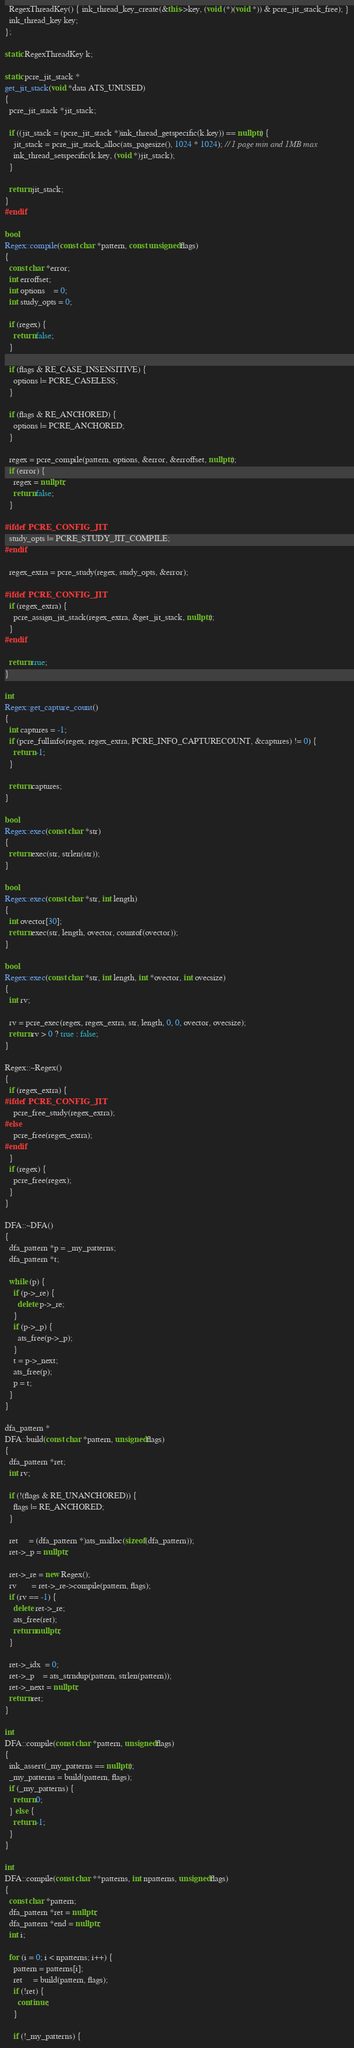<code> <loc_0><loc_0><loc_500><loc_500><_C++_>  RegexThreadKey() { ink_thread_key_create(&this->key, (void (*)(void *)) & pcre_jit_stack_free); }
  ink_thread_key key;
};

static RegexThreadKey k;

static pcre_jit_stack *
get_jit_stack(void *data ATS_UNUSED)
{
  pcre_jit_stack *jit_stack;

  if ((jit_stack = (pcre_jit_stack *)ink_thread_getspecific(k.key)) == nullptr) {
    jit_stack = pcre_jit_stack_alloc(ats_pagesize(), 1024 * 1024); // 1 page min and 1MB max
    ink_thread_setspecific(k.key, (void *)jit_stack);
  }

  return jit_stack;
}
#endif

bool
Regex::compile(const char *pattern, const unsigned flags)
{
  const char *error;
  int erroffset;
  int options    = 0;
  int study_opts = 0;

  if (regex) {
    return false;
  }

  if (flags & RE_CASE_INSENSITIVE) {
    options |= PCRE_CASELESS;
  }

  if (flags & RE_ANCHORED) {
    options |= PCRE_ANCHORED;
  }

  regex = pcre_compile(pattern, options, &error, &erroffset, nullptr);
  if (error) {
    regex = nullptr;
    return false;
  }

#ifdef PCRE_CONFIG_JIT
  study_opts |= PCRE_STUDY_JIT_COMPILE;
#endif

  regex_extra = pcre_study(regex, study_opts, &error);

#ifdef PCRE_CONFIG_JIT
  if (regex_extra) {
    pcre_assign_jit_stack(regex_extra, &get_jit_stack, nullptr);
  }
#endif

  return true;
}

int
Regex::get_capture_count()
{
  int captures = -1;
  if (pcre_fullinfo(regex, regex_extra, PCRE_INFO_CAPTURECOUNT, &captures) != 0) {
    return -1;
  }

  return captures;
}

bool
Regex::exec(const char *str)
{
  return exec(str, strlen(str));
}

bool
Regex::exec(const char *str, int length)
{
  int ovector[30];
  return exec(str, length, ovector, countof(ovector));
}

bool
Regex::exec(const char *str, int length, int *ovector, int ovecsize)
{
  int rv;

  rv = pcre_exec(regex, regex_extra, str, length, 0, 0, ovector, ovecsize);
  return rv > 0 ? true : false;
}

Regex::~Regex()
{
  if (regex_extra) {
#ifdef PCRE_CONFIG_JIT
    pcre_free_study(regex_extra);
#else
    pcre_free(regex_extra);
#endif
  }
  if (regex) {
    pcre_free(regex);
  }
}

DFA::~DFA()
{
  dfa_pattern *p = _my_patterns;
  dfa_pattern *t;

  while (p) {
    if (p->_re) {
      delete p->_re;
    }
    if (p->_p) {
      ats_free(p->_p);
    }
    t = p->_next;
    ats_free(p);
    p = t;
  }
}

dfa_pattern *
DFA::build(const char *pattern, unsigned flags)
{
  dfa_pattern *ret;
  int rv;

  if (!(flags & RE_UNANCHORED)) {
    flags |= RE_ANCHORED;
  }

  ret     = (dfa_pattern *)ats_malloc(sizeof(dfa_pattern));
  ret->_p = nullptr;

  ret->_re = new Regex();
  rv       = ret->_re->compile(pattern, flags);
  if (rv == -1) {
    delete ret->_re;
    ats_free(ret);
    return nullptr;
  }

  ret->_idx  = 0;
  ret->_p    = ats_strndup(pattern, strlen(pattern));
  ret->_next = nullptr;
  return ret;
}

int
DFA::compile(const char *pattern, unsigned flags)
{
  ink_assert(_my_patterns == nullptr);
  _my_patterns = build(pattern, flags);
  if (_my_patterns) {
    return 0;
  } else {
    return -1;
  }
}

int
DFA::compile(const char **patterns, int npatterns, unsigned flags)
{
  const char *pattern;
  dfa_pattern *ret = nullptr;
  dfa_pattern *end = nullptr;
  int i;

  for (i = 0; i < npatterns; i++) {
    pattern = patterns[i];
    ret     = build(pattern, flags);
    if (!ret) {
      continue;
    }

    if (!_my_patterns) {</code> 